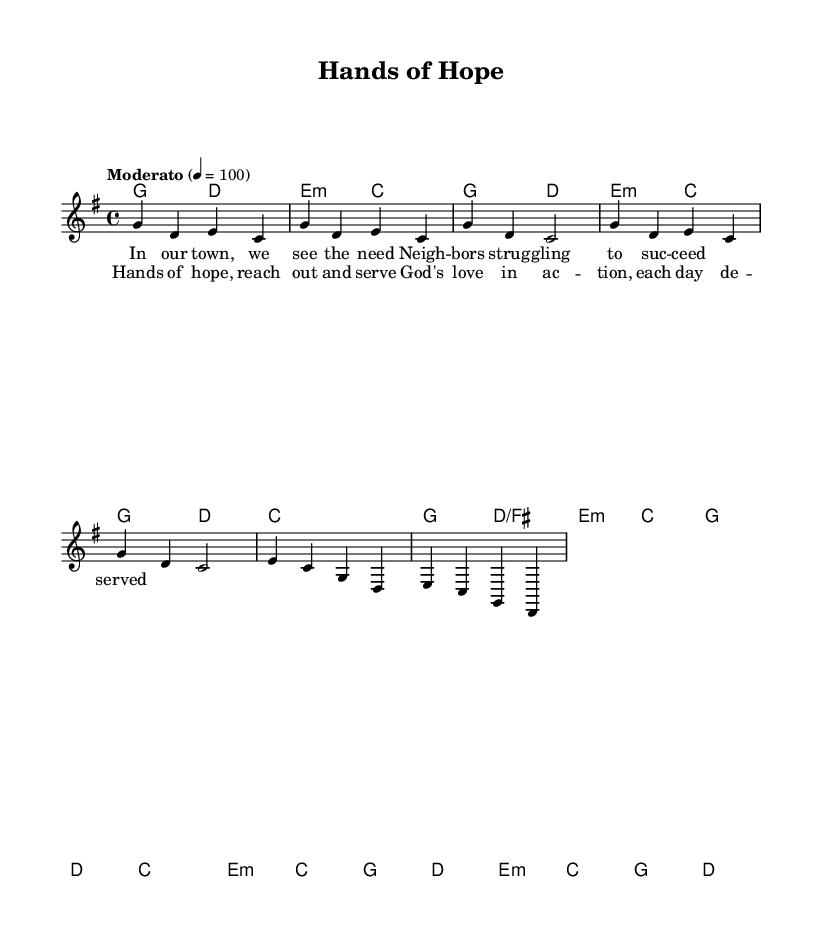What is the key signature of this music? The key signature is G major, which has one sharp (F#). This can be identified by looking at the key signature shown at the beginning of the sheet music.
Answer: G major What is the time signature of this music? The time signature is four-four, as indicated at the beginning of the piece. It means there are four beats in a measure and the quarter note gets one beat.
Answer: Four-four What is the tempo marking for this music? The tempo marking is "Moderato," which implies a moderate pace for the music. It's indicated alongside a specific metronome marking of 100 beats per minute.
Answer: Moderato How many lines are in the chorus lyrics? The chorus has two lines of lyrics. This can be seen in the lyric section corresponding to the melody, where there are two distinct phrases.
Answer: Two What is the last chord of the bridge? The last chord of the bridge is G major. In the harmonies section, the chord changes through the bridge are listed, and G major appears at the end.
Answer: G major What is the main theme of the lyrics in the verse? The main theme of the lyrics in the verse is about community need and neighborly struggle. Reading through the lyrics reveals a focus on local concerns and support.
Answer: Community need What is the climax of emotional expression in the chorus? The climax of emotional expression in the chorus is captured in the phrase "God's love in action." The use of this phrase stimulates a strong communal and uplifting response, emphasizing service and love.
Answer: God's love in action 